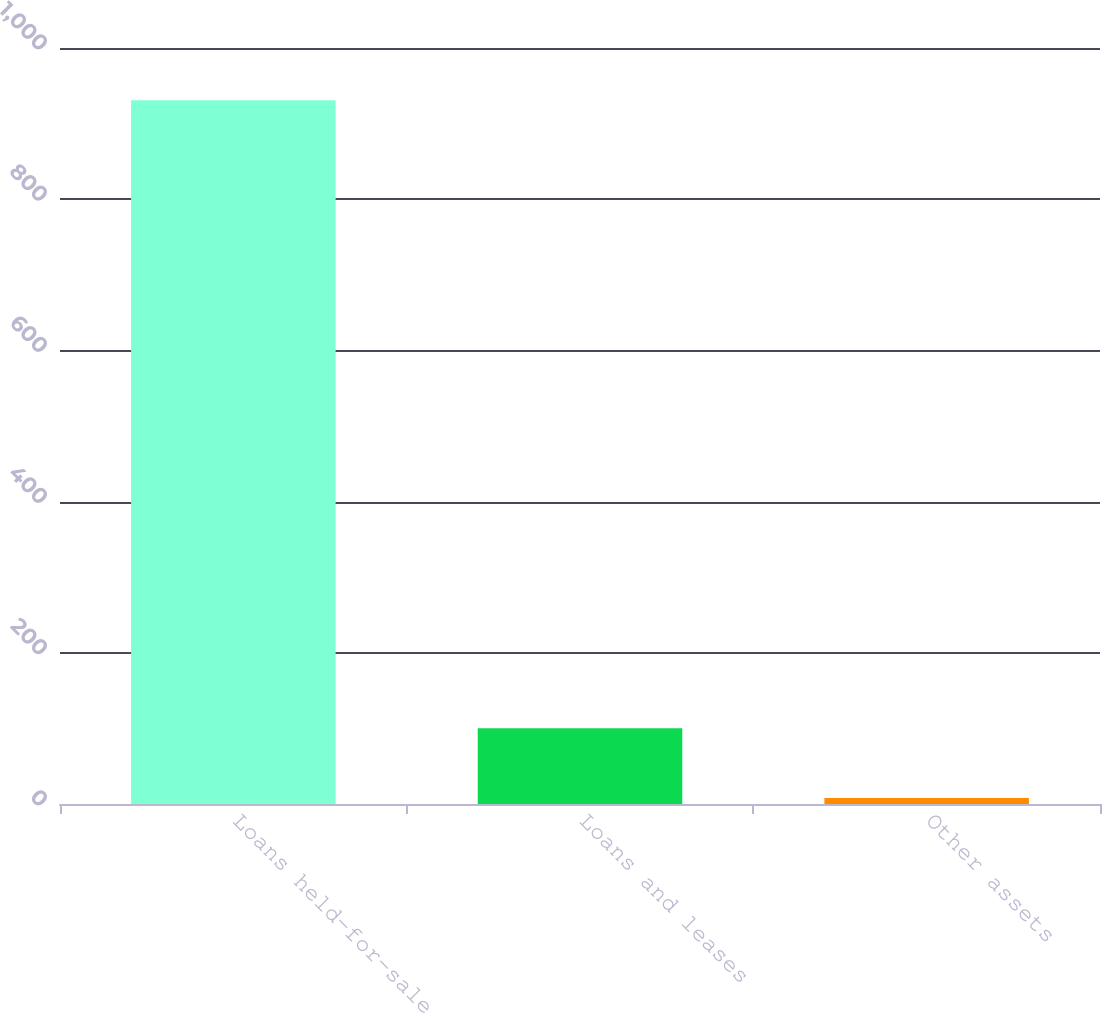<chart> <loc_0><loc_0><loc_500><loc_500><bar_chart><fcel>Loans held-for-sale<fcel>Loans and leases<fcel>Other assets<nl><fcel>931<fcel>100.3<fcel>8<nl></chart> 